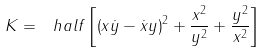<formula> <loc_0><loc_0><loc_500><loc_500>K = \ h a l f \left [ \left ( x \dot { y } - \dot { x } y \right ) ^ { 2 } + \frac { x ^ { 2 } } { y ^ { 2 } } + \frac { y ^ { 2 } } { x ^ { 2 } } \right ]</formula> 